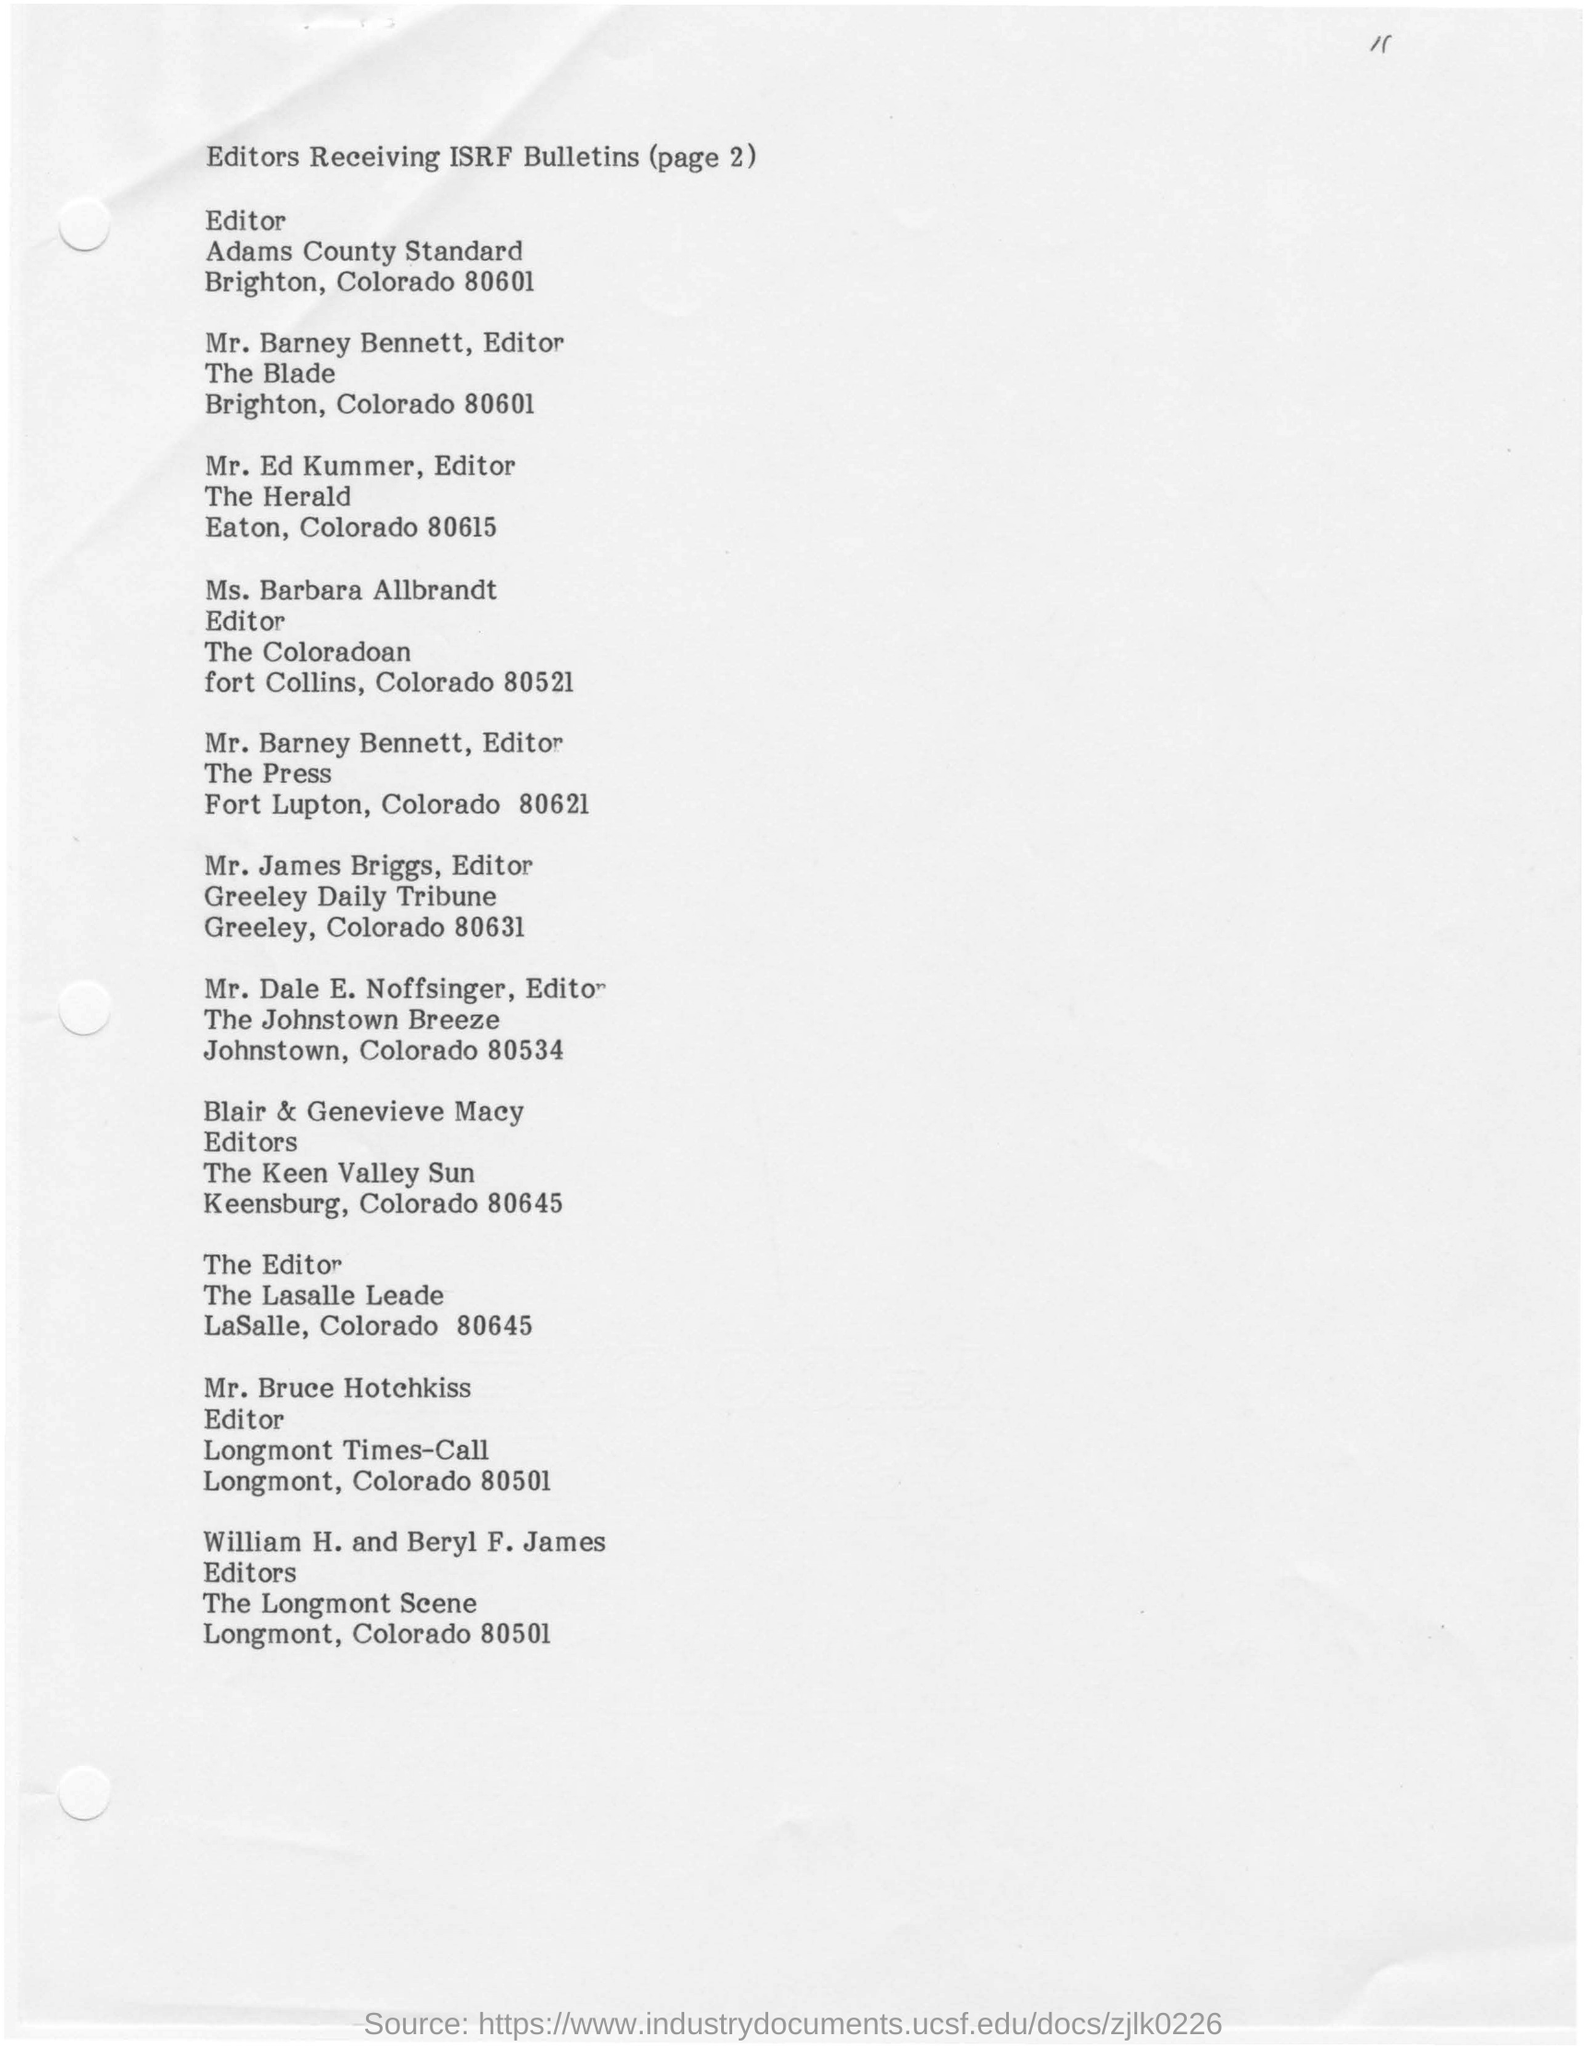Who is the editor of the coloradon?
Your response must be concise. Ms. Barbara Allbrandt. Where is  Mr.James Briggs working as an Editor?
Your response must be concise. Greeley Daily Tribune. Who are Blair and Genevieve Macy?
Your answer should be compact. Editors. 